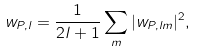<formula> <loc_0><loc_0><loc_500><loc_500>w _ { P , l } = \frac { 1 } { 2 l + 1 } \sum _ { m } | w _ { P , l m } | ^ { 2 } ,</formula> 